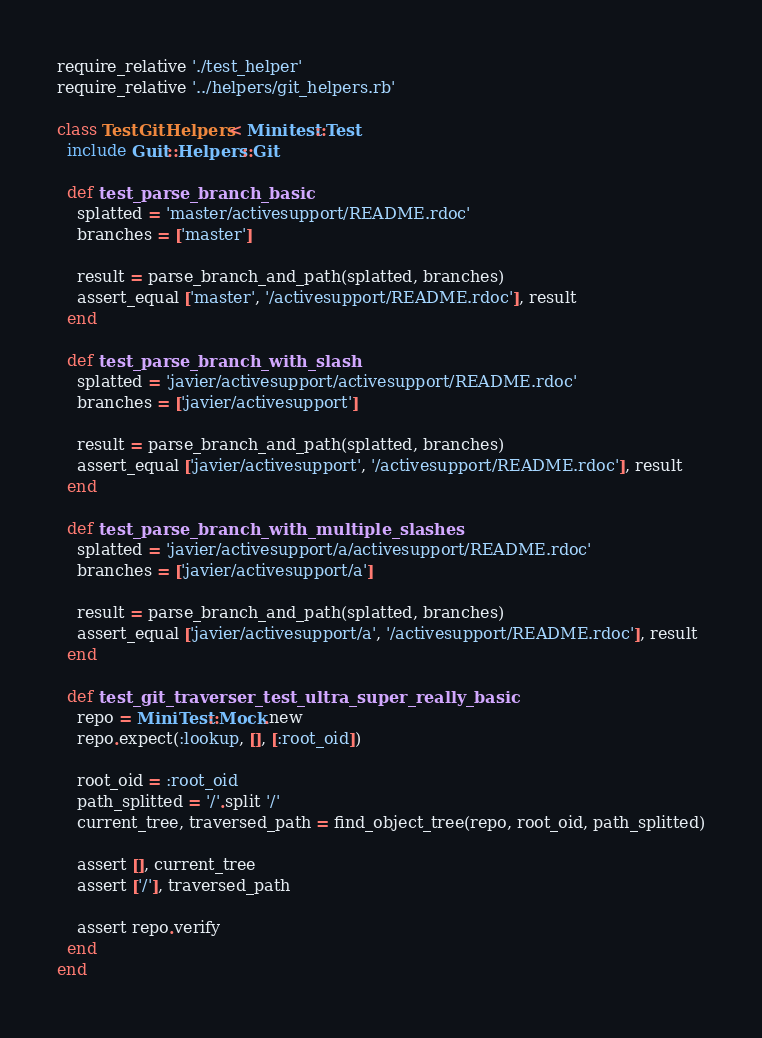Convert code to text. <code><loc_0><loc_0><loc_500><loc_500><_Ruby_>require_relative './test_helper'
require_relative '../helpers/git_helpers.rb'

class TestGitHelpers < Minitest::Test
  include Guit::Helpers::Git

  def test_parse_branch_basic
    splatted = 'master/activesupport/README.rdoc'
    branches = ['master']

    result = parse_branch_and_path(splatted, branches)
    assert_equal ['master', '/activesupport/README.rdoc'], result
  end

  def test_parse_branch_with_slash
    splatted = 'javier/activesupport/activesupport/README.rdoc'
    branches = ['javier/activesupport']

    result = parse_branch_and_path(splatted, branches)
    assert_equal ['javier/activesupport', '/activesupport/README.rdoc'], result
  end

  def test_parse_branch_with_multiple_slashes
    splatted = 'javier/activesupport/a/activesupport/README.rdoc'
    branches = ['javier/activesupport/a']

    result = parse_branch_and_path(splatted, branches)
    assert_equal ['javier/activesupport/a', '/activesupport/README.rdoc'], result
  end

  def test_git_traverser_test_ultra_super_really_basic
    repo = MiniTest::Mock.new
    repo.expect(:lookup, [], [:root_oid])

    root_oid = :root_oid
    path_splitted = '/'.split '/'
    current_tree, traversed_path = find_object_tree(repo, root_oid, path_splitted)

    assert [], current_tree
    assert ['/'], traversed_path

    assert repo.verify
  end
end
</code> 